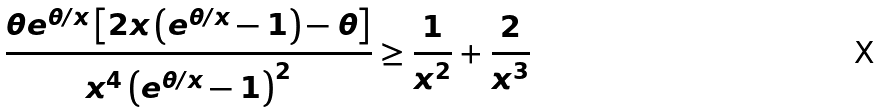Convert formula to latex. <formula><loc_0><loc_0><loc_500><loc_500>\frac { \theta e ^ { \theta / x } \left [ 2 x \left ( e ^ { \theta / x } - 1 \right ) - \theta \right ] } { x ^ { 4 } \left ( e ^ { \theta / x } - 1 \right ) ^ { 2 } } \geq \frac { 1 } { x ^ { 2 } } + \frac { 2 } { x ^ { 3 } }</formula> 